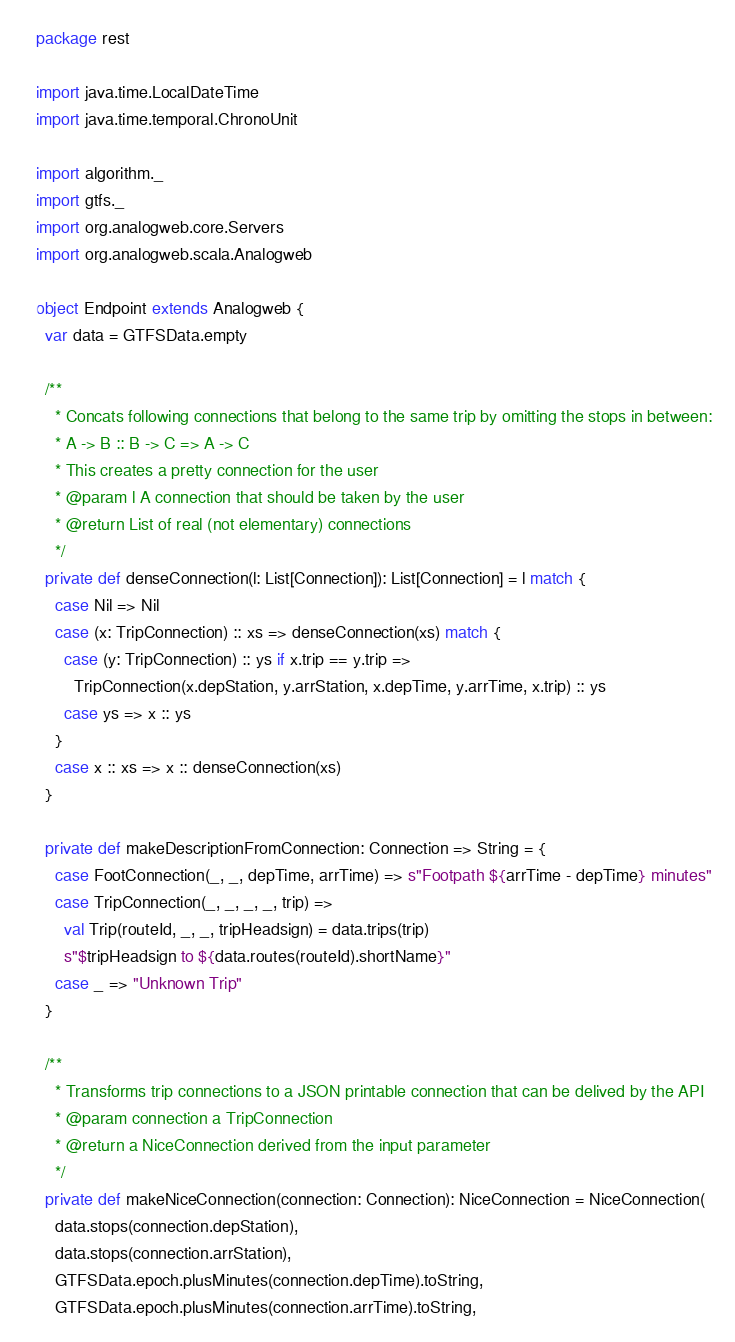<code> <loc_0><loc_0><loc_500><loc_500><_Scala_>package rest

import java.time.LocalDateTime
import java.time.temporal.ChronoUnit

import algorithm._
import gtfs._
import org.analogweb.core.Servers
import org.analogweb.scala.Analogweb

object Endpoint extends Analogweb {
  var data = GTFSData.empty

  /**
    * Concats following connections that belong to the same trip by omitting the stops in between:
    * A -> B :: B -> C => A -> C
    * This creates a pretty connection for the user
    * @param l A connection that should be taken by the user
    * @return List of real (not elementary) connections
    */
  private def denseConnection(l: List[Connection]): List[Connection] = l match {
    case Nil => Nil
    case (x: TripConnection) :: xs => denseConnection(xs) match {
      case (y: TripConnection) :: ys if x.trip == y.trip =>
        TripConnection(x.depStation, y.arrStation, x.depTime, y.arrTime, x.trip) :: ys
      case ys => x :: ys
    }
    case x :: xs => x :: denseConnection(xs)
  }

  private def makeDescriptionFromConnection: Connection => String = {
    case FootConnection(_, _, depTime, arrTime) => s"Footpath ${arrTime - depTime} minutes"
    case TripConnection(_, _, _, _, trip) =>
      val Trip(routeId, _, _, tripHeadsign) = data.trips(trip)
      s"$tripHeadsign to ${data.routes(routeId).shortName}"
    case _ => "Unknown Trip"
  }

  /**
    * Transforms trip connections to a JSON printable connection that can be delived by the API
    * @param connection a TripConnection
    * @return a NiceConnection derived from the input parameter
    */
  private def makeNiceConnection(connection: Connection): NiceConnection = NiceConnection(
    data.stops(connection.depStation),
    data.stops(connection.arrStation),
    GTFSData.epoch.plusMinutes(connection.depTime).toString,
    GTFSData.epoch.plusMinutes(connection.arrTime).toString,</code> 